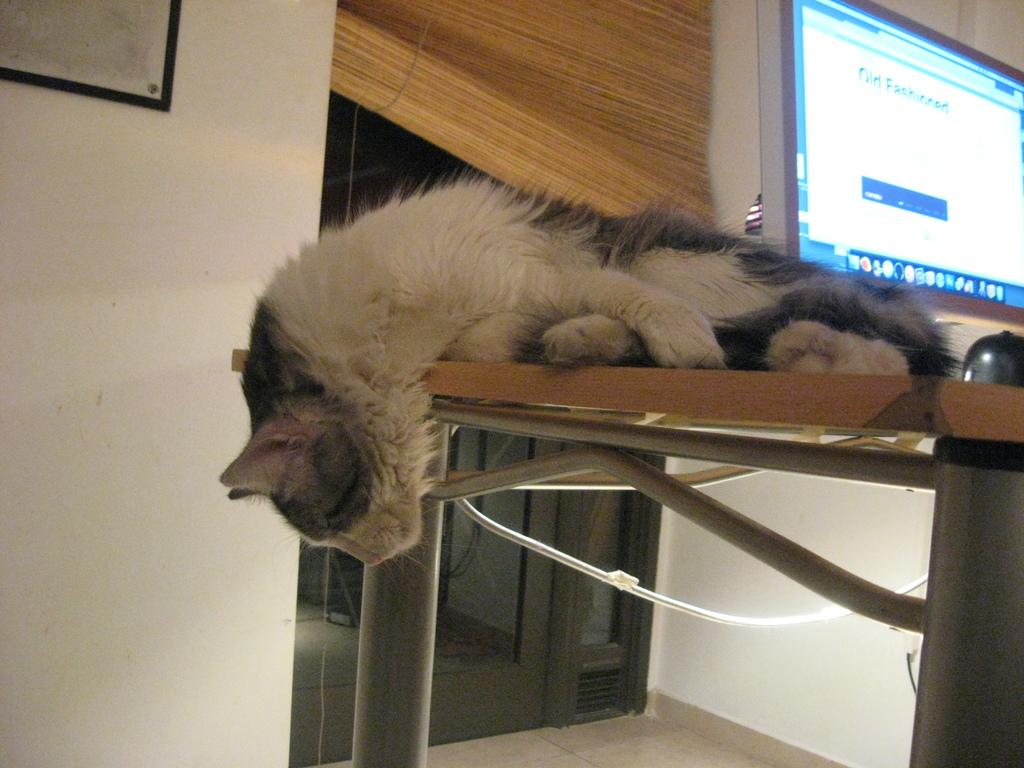What animal can be seen lying on the table in the image? There is a cat lying on a table in the image. What electronic device is visible in the background of the image? There is a monitor in the background of the image. What type of window covering is present in the background of the image? There is a window blind in the background of the image. What architectural feature is visible in the background of the image? There is a window in the background of the image. What is attached to the wall in the background of the image? There is a photo frame attached to the wall in the background of the image. Can you hear the sound of rain in the image? There is no mention of rain or any sound in the image, so it cannot be determined from the image alone. 